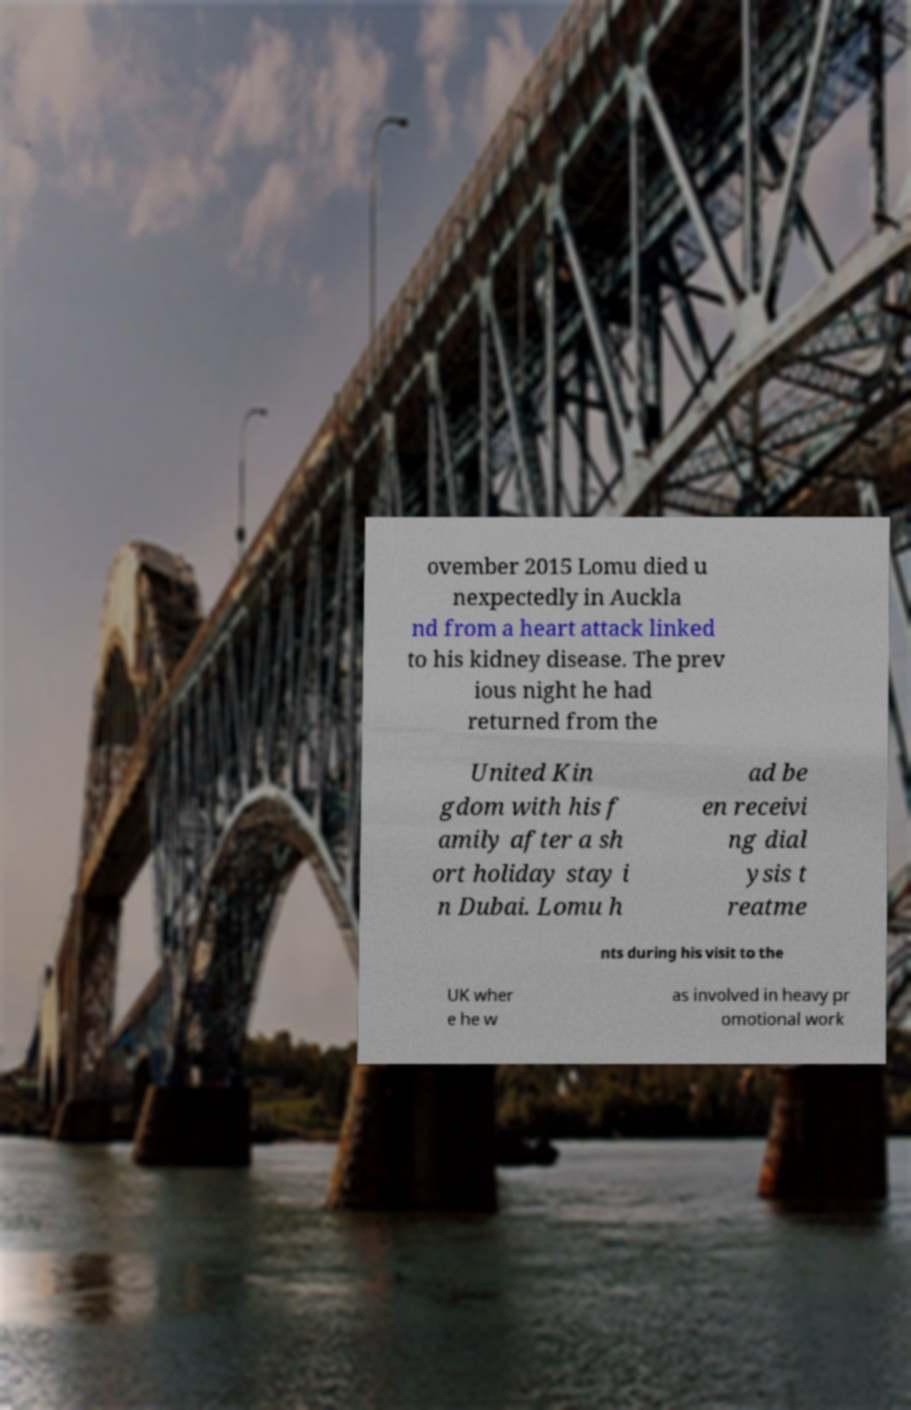Can you read and provide the text displayed in the image?This photo seems to have some interesting text. Can you extract and type it out for me? ovember 2015 Lomu died u nexpectedly in Auckla nd from a heart attack linked to his kidney disease. The prev ious night he had returned from the United Kin gdom with his f amily after a sh ort holiday stay i n Dubai. Lomu h ad be en receivi ng dial ysis t reatme nts during his visit to the UK wher e he w as involved in heavy pr omotional work 